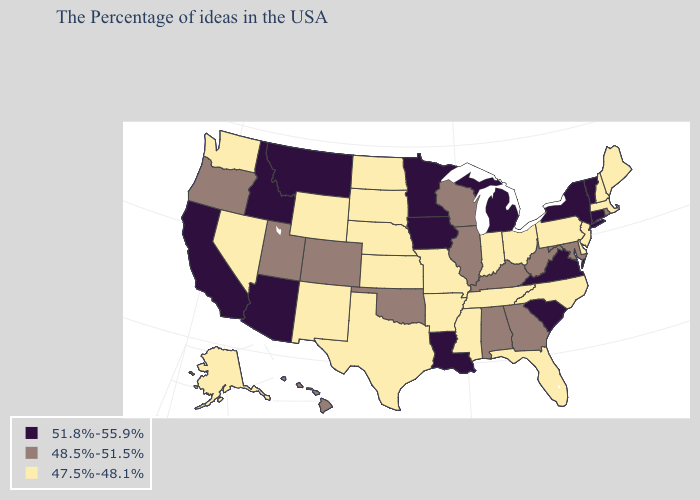What is the highest value in states that border Kansas?
Short answer required. 48.5%-51.5%. Name the states that have a value in the range 48.5%-51.5%?
Give a very brief answer. Rhode Island, Maryland, West Virginia, Georgia, Kentucky, Alabama, Wisconsin, Illinois, Oklahoma, Colorado, Utah, Oregon, Hawaii. What is the lowest value in the USA?
Concise answer only. 47.5%-48.1%. Which states hav the highest value in the MidWest?
Quick response, please. Michigan, Minnesota, Iowa. Does South Carolina have a higher value than Arizona?
Write a very short answer. No. Name the states that have a value in the range 48.5%-51.5%?
Keep it brief. Rhode Island, Maryland, West Virginia, Georgia, Kentucky, Alabama, Wisconsin, Illinois, Oklahoma, Colorado, Utah, Oregon, Hawaii. Does the map have missing data?
Concise answer only. No. Which states hav the highest value in the West?
Give a very brief answer. Montana, Arizona, Idaho, California. What is the highest value in the USA?
Concise answer only. 51.8%-55.9%. Does Connecticut have the same value as North Dakota?
Short answer required. No. What is the value of South Dakota?
Give a very brief answer. 47.5%-48.1%. Name the states that have a value in the range 48.5%-51.5%?
Write a very short answer. Rhode Island, Maryland, West Virginia, Georgia, Kentucky, Alabama, Wisconsin, Illinois, Oklahoma, Colorado, Utah, Oregon, Hawaii. Does Montana have a higher value than Idaho?
Answer briefly. No. What is the value of Kansas?
Write a very short answer. 47.5%-48.1%. What is the value of West Virginia?
Keep it brief. 48.5%-51.5%. 